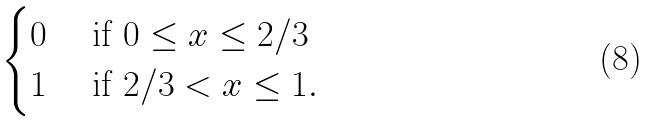<formula> <loc_0><loc_0><loc_500><loc_500>\begin{cases} 0 & \text { if } 0 \leq x \leq 2 / 3 \\ 1 & \text { if } 2 / 3 < x \leq 1 . \end{cases}</formula> 